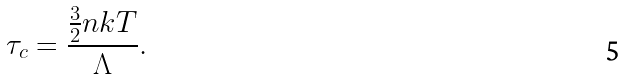Convert formula to latex. <formula><loc_0><loc_0><loc_500><loc_500>\tau _ { c } = \frac { \frac { 3 } { 2 } n k T } { \Lambda } .</formula> 